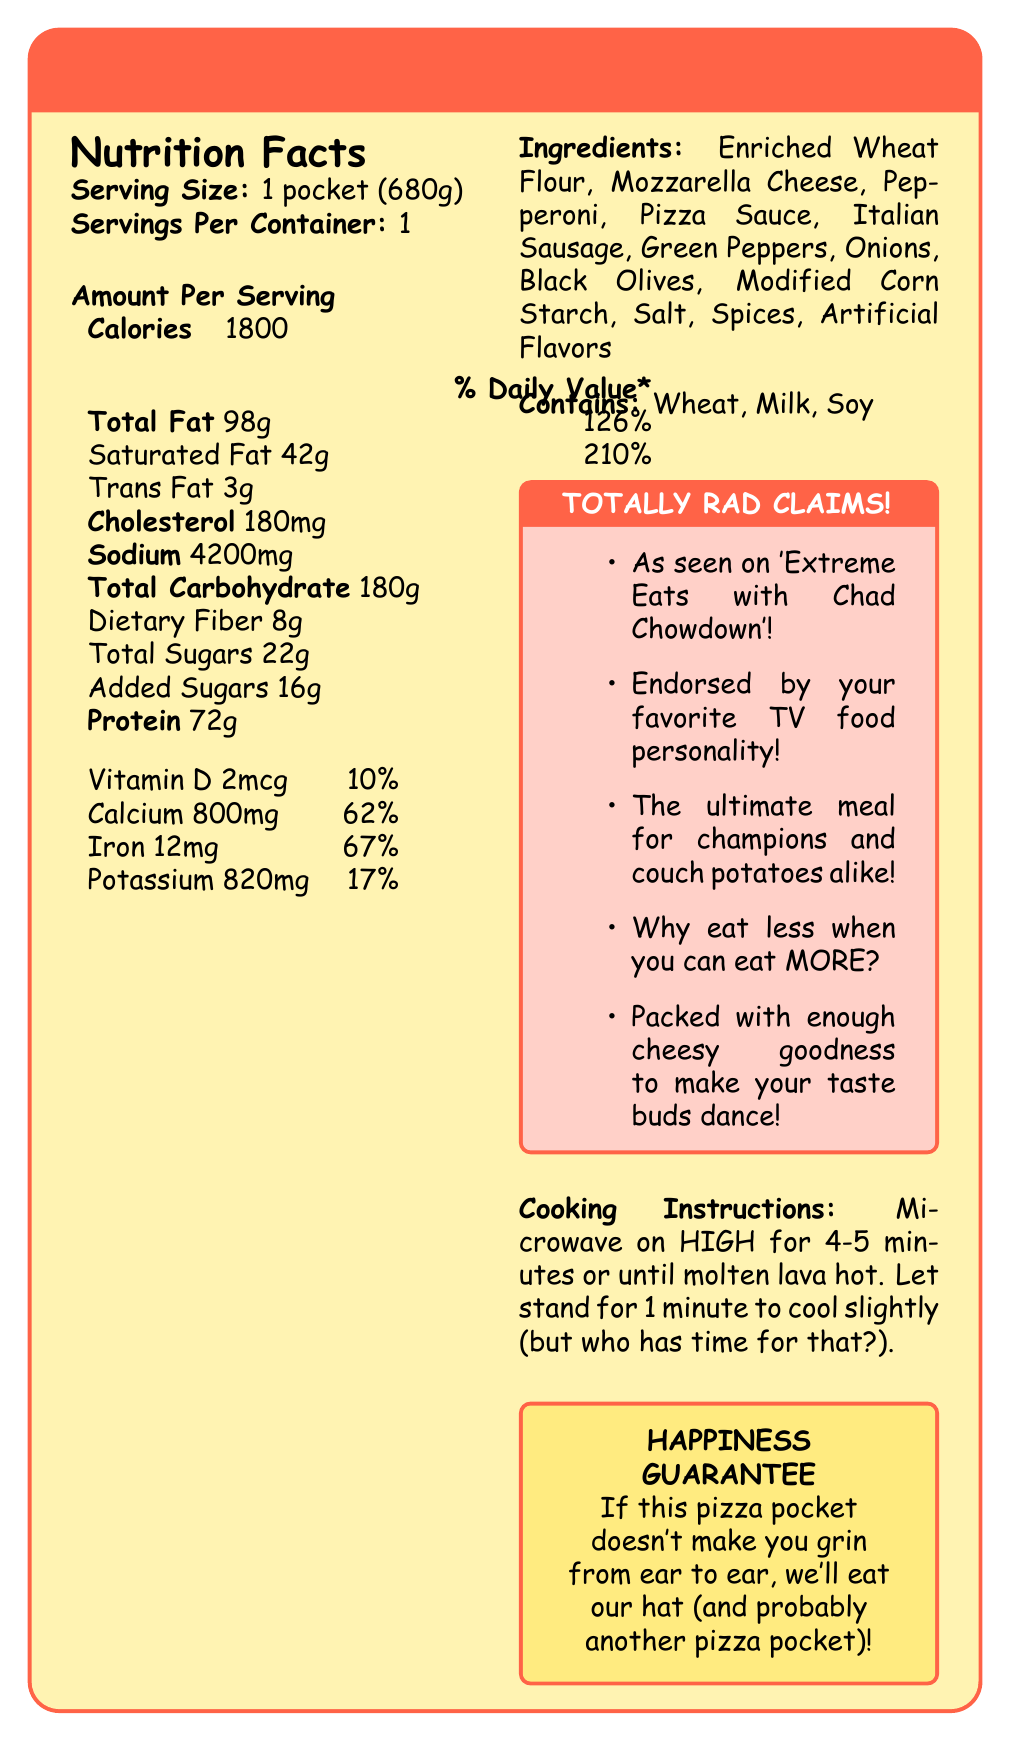what is the serving size of the XL Supreme Pizza Pocket? The serving size is clearly mentioned at the start of the Nutrition Facts section.
Answer: 1 pocket (680g) how many calories are in one serving of the XL Supreme Pizza Pocket? The calories per serving are listed in the Amount Per Serving section.
Answer: 1800 what percentage of the daily value of sodium does the XL Supreme Pizza Pocket contain? The Nutrition Facts section lists 4200mg of sodium, which is 183% of the daily value.
Answer: 183% what are the main allergens listed in the XL Supreme Pizza Pocket? The allergens are listed under the "Contains" section.
Answer: Wheat, Milk, Soy how much protein does the XL Supreme Pizza Pocket provide? The amount of protein per serving is shown in the Nutrition Facts section.
Answer: 72g how many servings are in one container of XL Supreme Pizza Pocket? The servings per container are indicated as 1 in the Nutrition Facts section.
Answer: 1 what is the total amount of saturated fat in one serving? A. 40g B. 42g C. 45g D. 50g The Nutrition Facts section indicates that there are 42g of saturated fat per serving.
Answer: B. 42g what is the correct cooking time for the XL Supreme Pizza Pocket? A. 2-3 minutes B. 3-4 minutes C. 4-5 minutes D. 5-6 minutes The cooking instructions say to microwave on HIGH for 4-5 minutes.
Answer: C. 4-5 minutes is the XL Supreme Pizza Pocket endorsed by a TV food personality? The marketing claims mention that it is endorsed by your favorite TV food personality.
Answer: Yes what are the cooking instructions for the XL Supreme Pizza Pocket? The cooking instructions are detailed under the Cooking Instructions section.
Answer: Microwave on HIGH for 4-5 minutes or until molten lava hot. Let stand for 1 minute to cool slightly (but who has time for that?). describe the main idea of the document This summary includes the nutritional information, marketing claims, allergens, and cooking instructions, capturing the main aspects of the document.
Answer: The XL Supreme Pizza Pocket is a high-calorie, large serving microwaveable pizza with exaggerated serving sizes. It packs a significant amount of fat, sodium, and protein per serving. The packaging includes bold marketing claims about its endorsement by a TV food personality and promises to make consumers happy. The product includes allergens such as wheat, milk, and soy, and provides various nutrients like calcium, iron, and vitamins. Cooking instructions are provided to ensure the perfect experience. what is the calorie count for half a serving of the XL Supreme Pizza Pocket? The document only provides information for a full serving size (1 pocket), so the calorie count for half a serving cannot be determined.
Answer: Cannot be determined how much iron does one serving provide, and what is the % Daily Value? The Nutrition Facts section indicates the iron content as 12mg, which is 67% of the daily value.
Answer: 12mg, 67% 